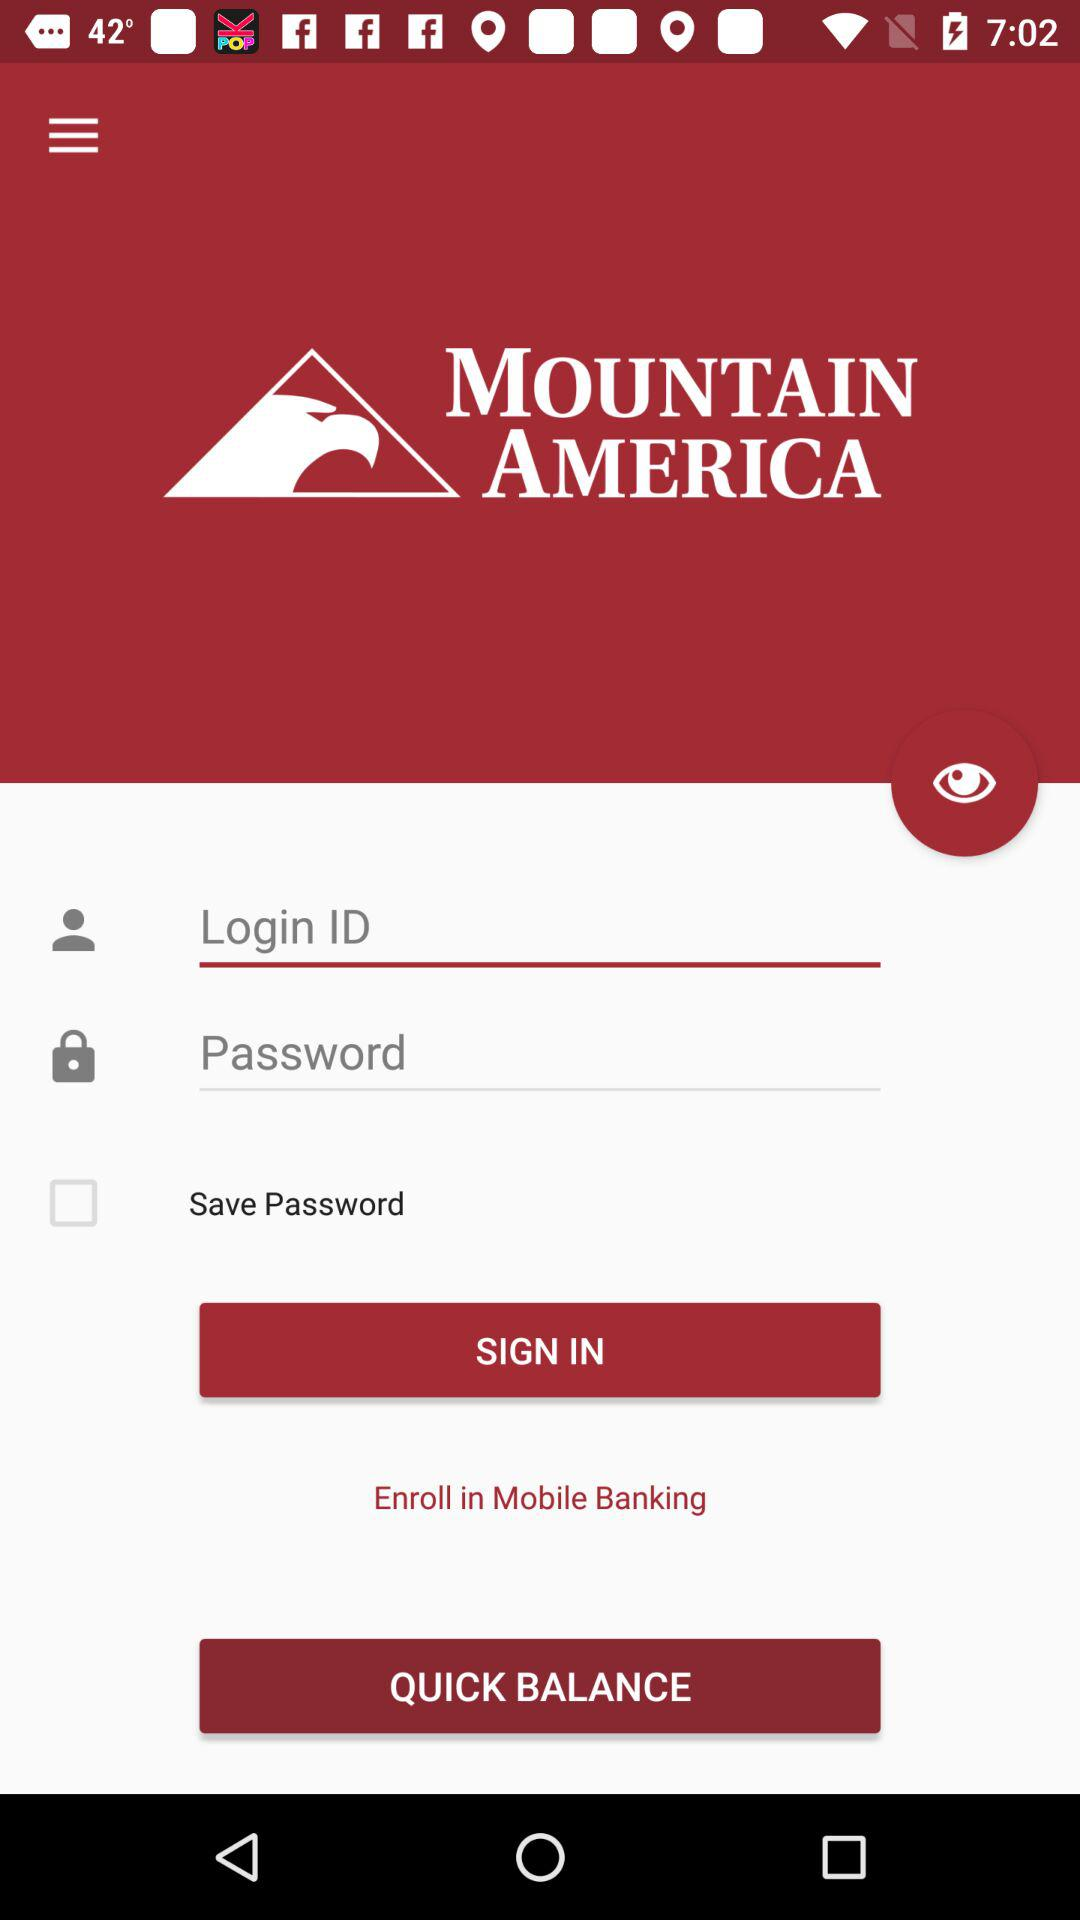What is the status of "Save Password"? The status is "off". 